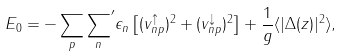<formula> <loc_0><loc_0><loc_500><loc_500>E _ { 0 } = - \sum _ { p } { \sum _ { n } } ^ { \prime } \epsilon _ { n } \left [ ( v ^ { \uparrow } _ { n p } ) ^ { 2 } + ( v ^ { \downarrow } _ { n p } ) ^ { 2 } \right ] + \frac { 1 } { g } \langle | \Delta ( z ) | ^ { 2 } \rangle ,</formula> 